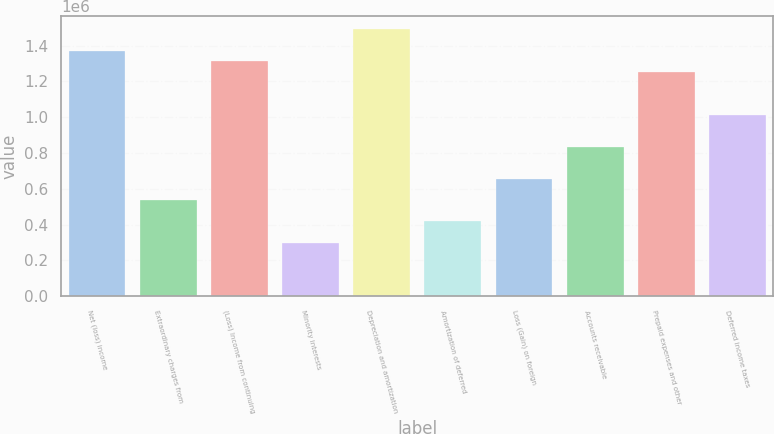Convert chart. <chart><loc_0><loc_0><loc_500><loc_500><bar_chart><fcel>Net (loss) income<fcel>Extraordinary charges from<fcel>(Loss) Income from continuing<fcel>Minority interests<fcel>Depreciation and amortization<fcel>Amortization of deferred<fcel>Loss (Gain) on foreign<fcel>Accounts receivable<fcel>Prepaid expenses and other<fcel>Deferred income taxes<nl><fcel>1.37192e+06<fcel>536846<fcel>1.31227e+06<fcel>298254<fcel>1.49121e+06<fcel>417550<fcel>656142<fcel>835086<fcel>1.25262e+06<fcel>1.01403e+06<nl></chart> 